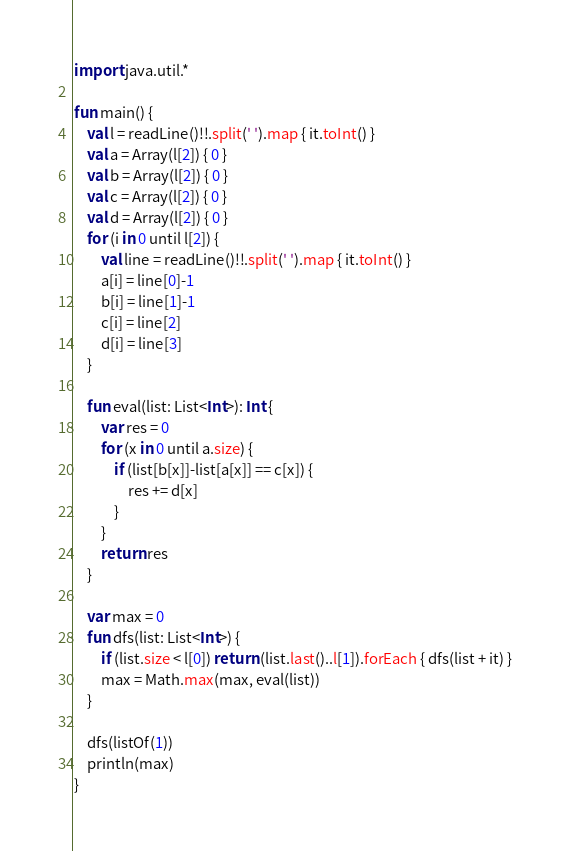Convert code to text. <code><loc_0><loc_0><loc_500><loc_500><_Kotlin_>import java.util.*

fun main() {
    val l = readLine()!!.split(' ').map { it.toInt() }
    val a = Array(l[2]) { 0 }
    val b = Array(l[2]) { 0 }
    val c = Array(l[2]) { 0 }
    val d = Array(l[2]) { 0 }
    for (i in 0 until l[2]) {
        val line = readLine()!!.split(' ').map { it.toInt() }
        a[i] = line[0]-1
        b[i] = line[1]-1
        c[i] = line[2]
        d[i] = line[3]
    }

    fun eval(list: List<Int>): Int {
        var res = 0
        for (x in 0 until a.size) {
            if (list[b[x]]-list[a[x]] == c[x]) {
                res += d[x]
            }
        }
        return res
    }

    var max = 0
    fun dfs(list: List<Int>) {
        if (list.size < l[0]) return (list.last()..l[1]).forEach { dfs(list + it) }
        max = Math.max(max, eval(list))
    }

    dfs(listOf(1))
    println(max)
}

</code> 